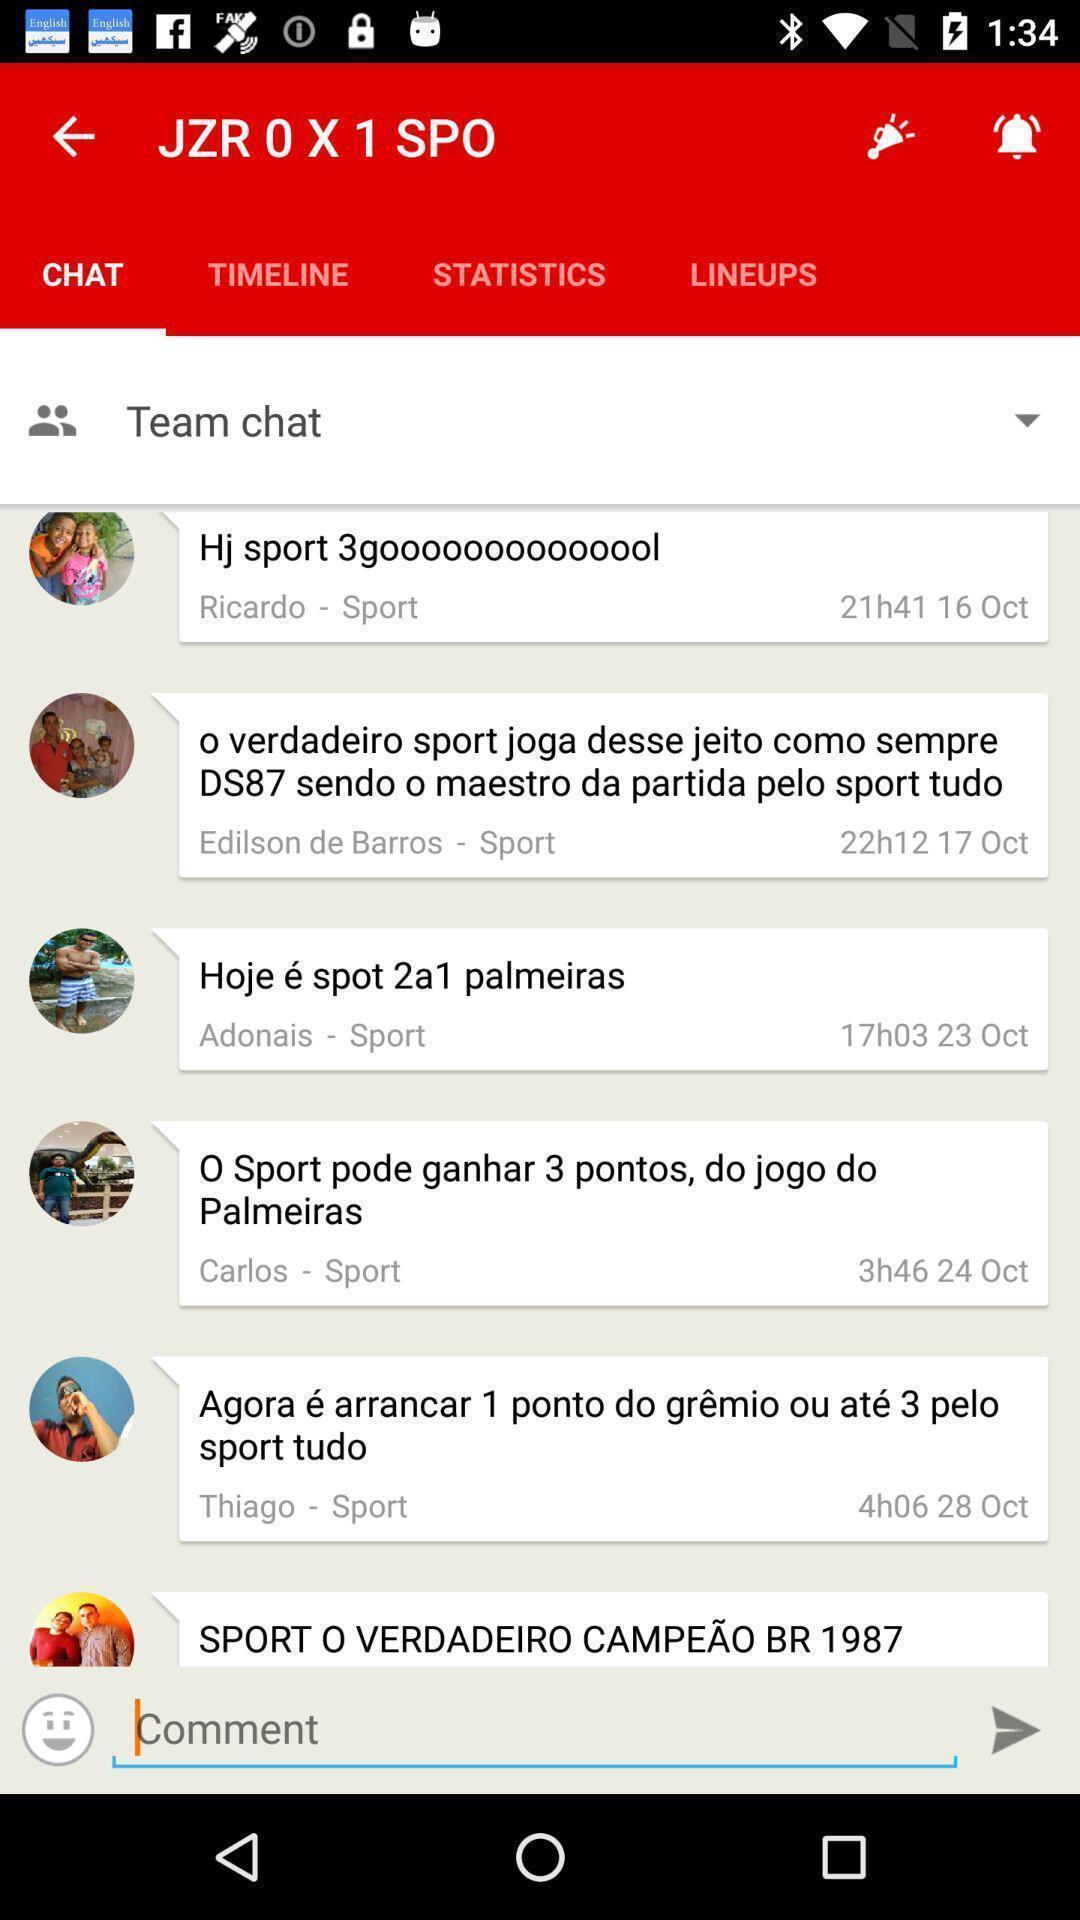Tell me about the visual elements in this screen capture. Screen showing a team chat. 